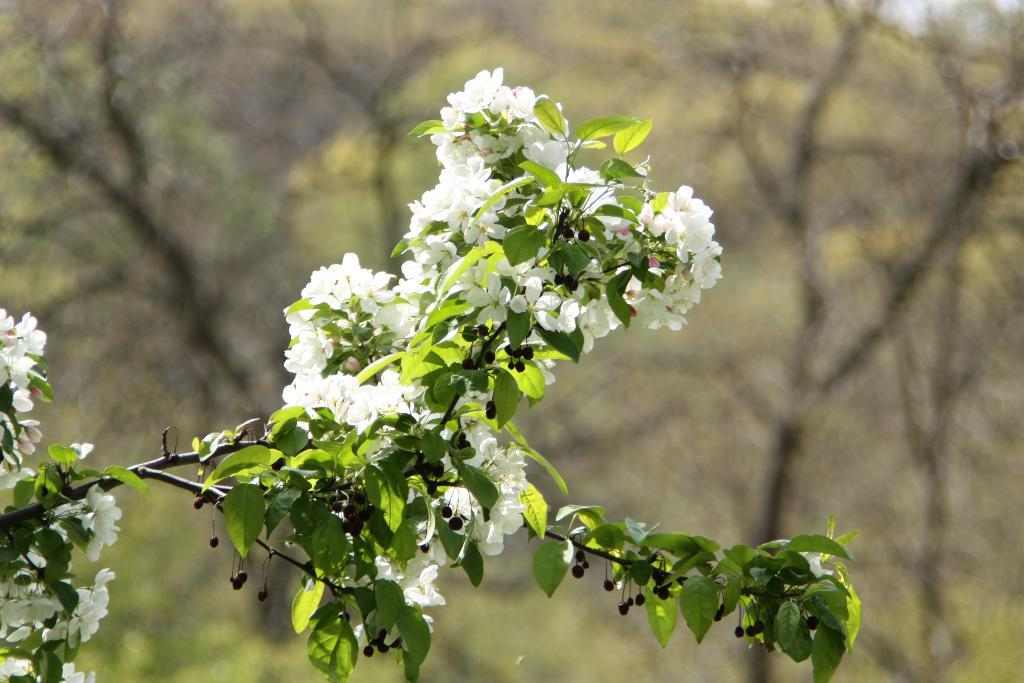What type of vegetation can be seen in the image? There are leaves and white color flowers on stems in the image. What can be seen in the background of the image? There are trees in the background of the image. How is the background of the image depicted? The background of the image is blurred. What type of calculator can be seen in the image? There is no calculator present in the image. What plot of land is depicted in the image? The image does not show a specific plot of land; it features leaves, flowers, and trees. 